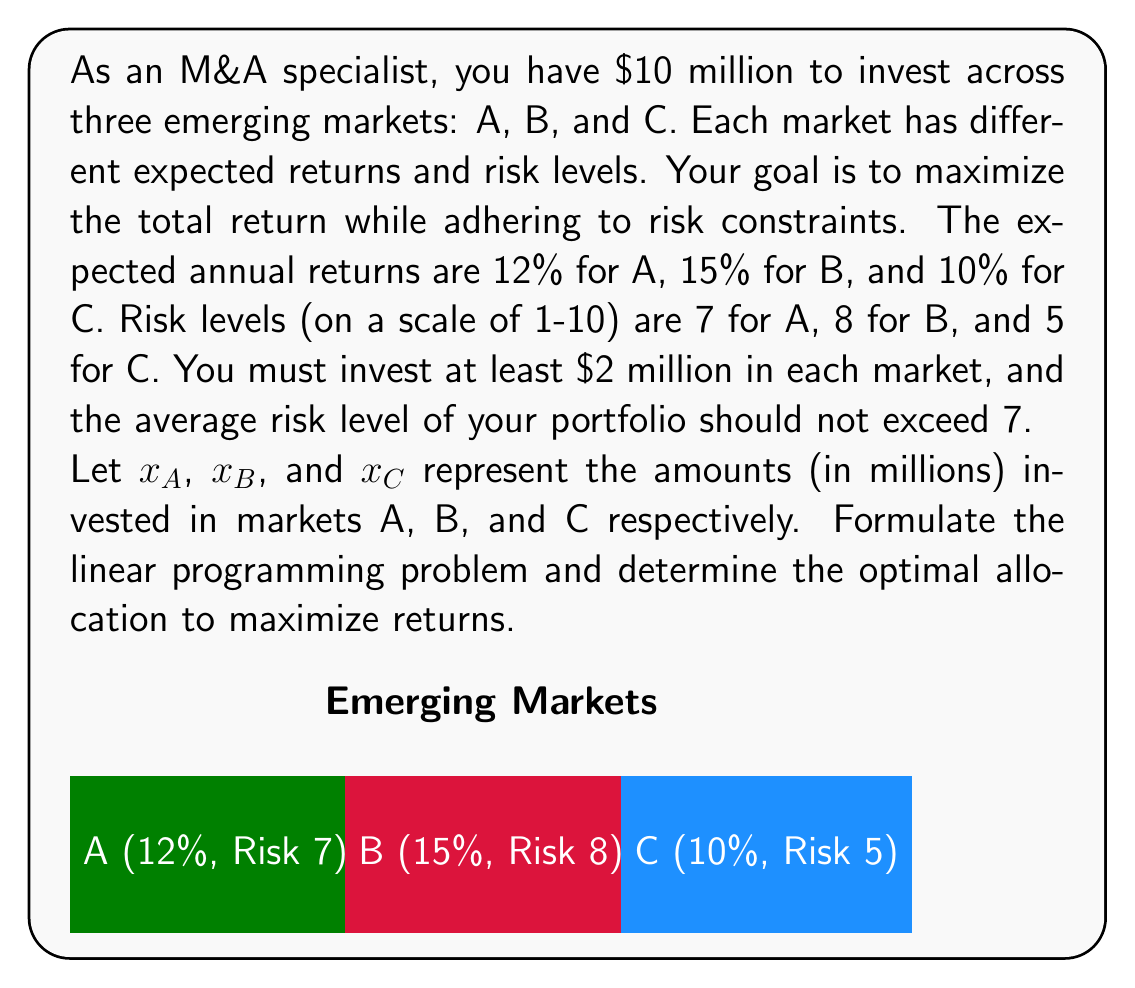Show me your answer to this math problem. Let's approach this step-by-step:

1) Objective function:
   We want to maximize the total return. The objective function is:
   $$\text{Maximize } Z = 0.12x_A + 0.15x_B + 0.10x_C$$

2) Constraints:
   a) Total investment constraint:
      $$x_A + x_B + x_C = 10$$
   
   b) Minimum investment in each market:
      $$x_A \geq 2, x_B \geq 2, x_C \geq 2$$
   
   c) Average risk constraint:
      $$\frac{7x_A + 8x_B + 5x_C}{x_A + x_B + x_C} \leq 7$$
      
      This can be simplified to:
      $$7x_A + 8x_B + 5x_C \leq 7(x_A + x_B + x_C)$$
      $$\Rightarrow 0x_A + 1x_B - 2x_C \leq 0$$

3) Non-negativity constraints:
   $$x_A, x_B, x_C \geq 0$$

4) Solving the linear programming problem:
   We can use the simplex method or a linear programming solver to find the optimal solution.

5) The optimal solution is:
   $$x_A = 2, x_B = 4, x_C = 4$$

6) Verification:
   - Total investment: $2 + 4 + 4 = 10$ million
   - Minimum investment constraint is satisfied for all markets
   - Average risk: $\frac{7(2) + 8(4) + 5(4)}{10} = 6.8 \leq 7$
   - Total return: $0.12(2) + 0.15(4) + 0.10(4) = 1.24$ million or 12.4%

Therefore, the optimal allocation is to invest $2 million in market A, $4 million in market B, and $4 million in market C.
Answer: $x_A = 2, x_B = 4, x_C = 4$ (in millions) 